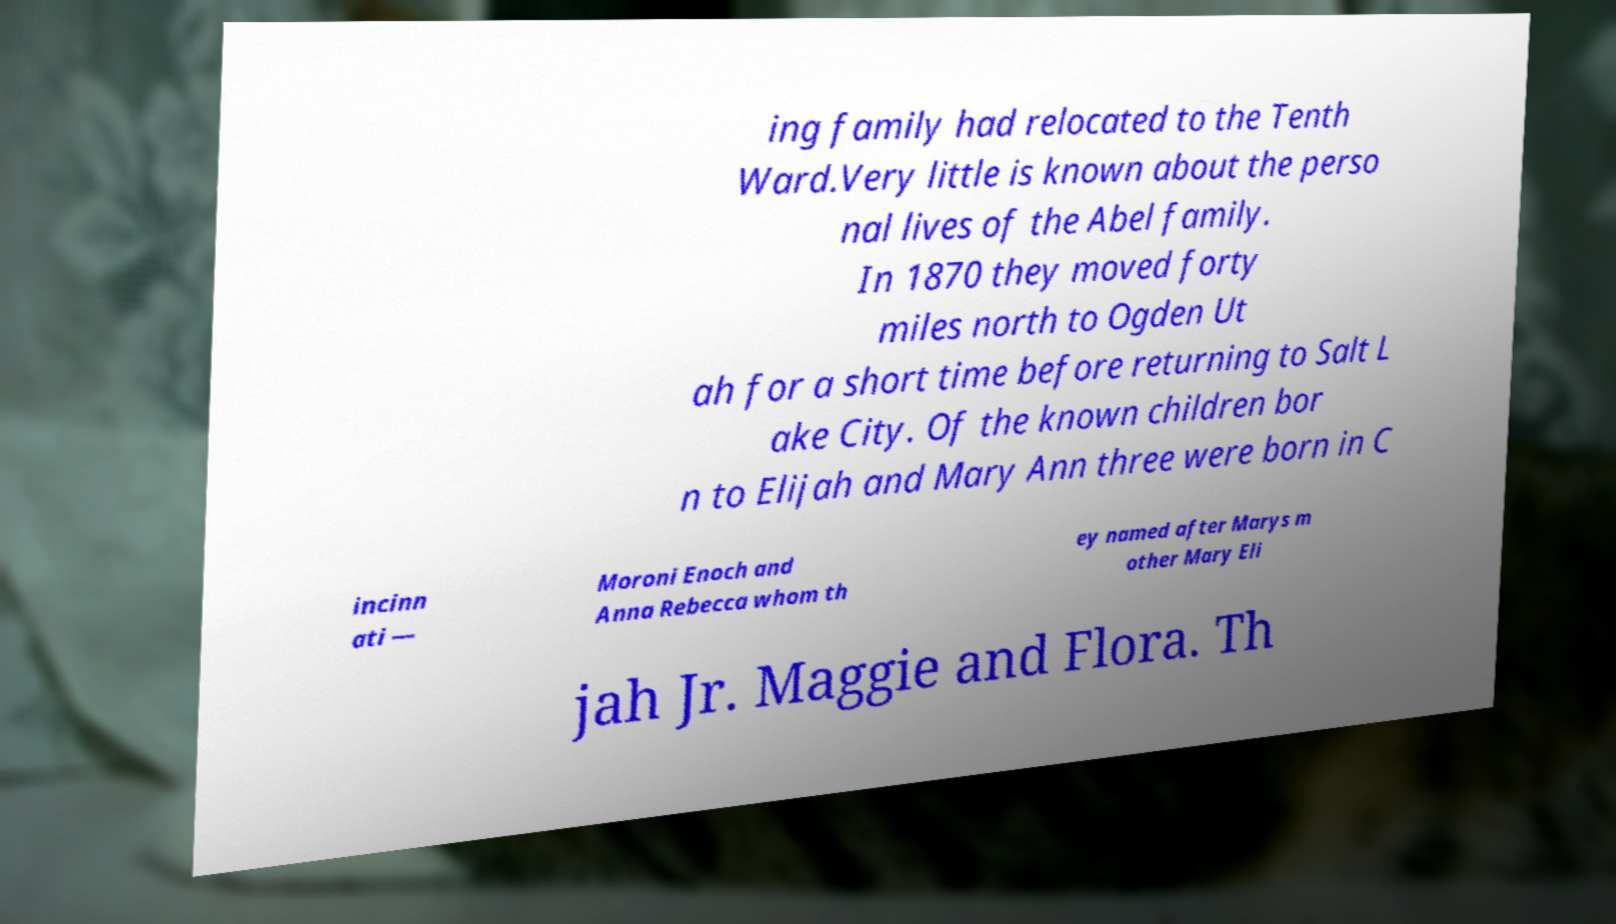I need the written content from this picture converted into text. Can you do that? ing family had relocated to the Tenth Ward.Very little is known about the perso nal lives of the Abel family. In 1870 they moved forty miles north to Ogden Ut ah for a short time before returning to Salt L ake City. Of the known children bor n to Elijah and Mary Ann three were born in C incinn ati — Moroni Enoch and Anna Rebecca whom th ey named after Marys m other Mary Eli jah Jr. Maggie and Flora. Th 